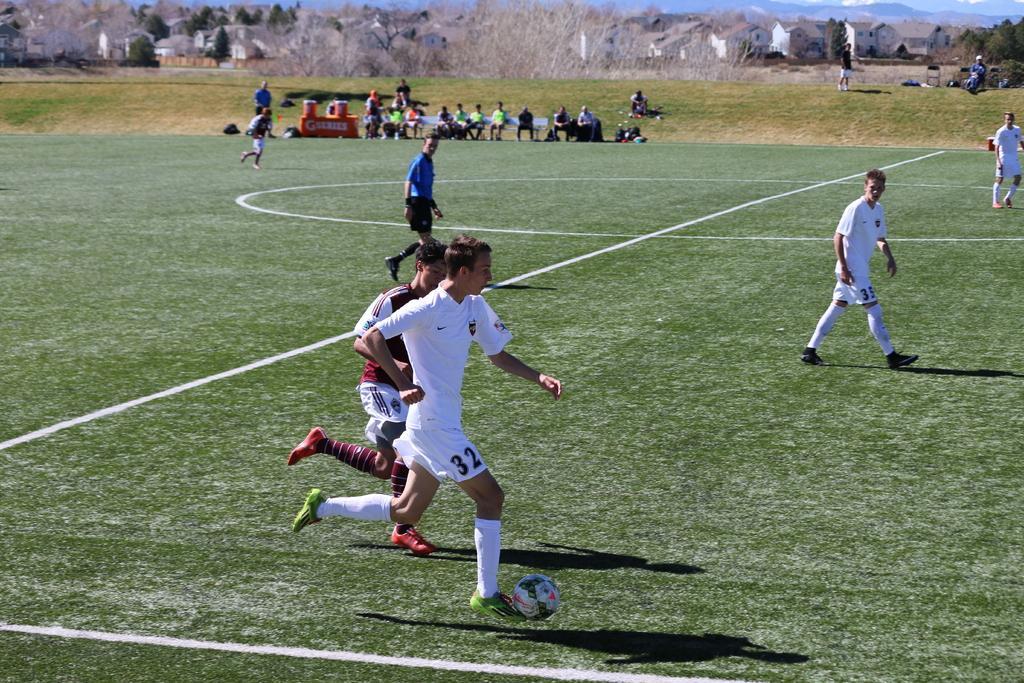Please provide a concise description of this image. In this picture we can find a people running a ball on the ground, the ground is green in colour with grass. In the background we can find some people are sitting on the chairs and there are houses, trees, sky. 